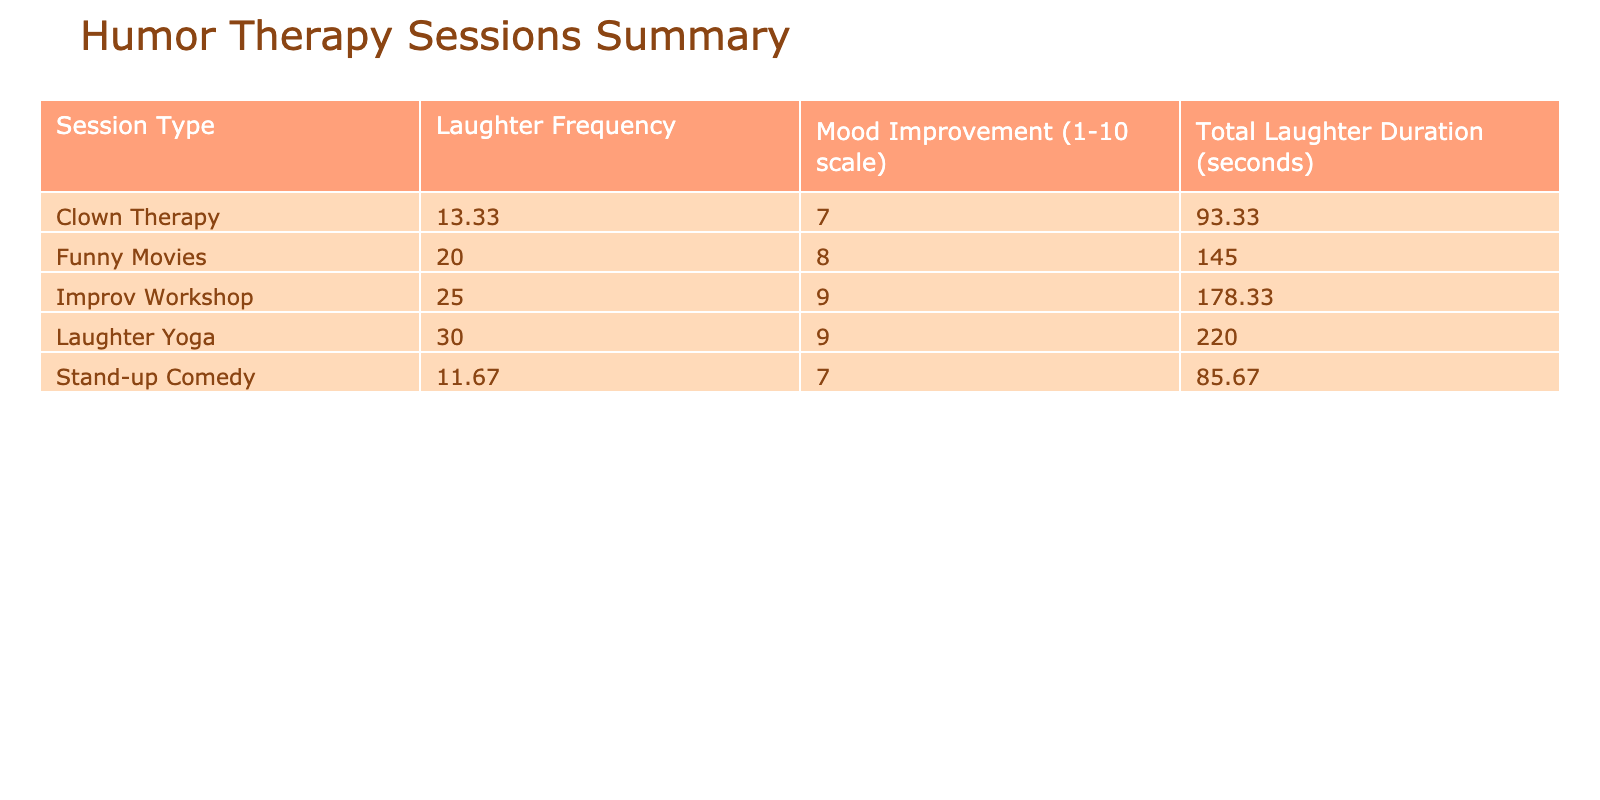What is the average laughter frequency during Funny Movies? The laughter frequencies for Funny Movies are 20, 18, and 22. To find the average, sum these values: 20 + 18 + 22 = 60, and then divide by the number of sessions (3): 60 / 3 = 20.
Answer: 20 Which session type had the highest mood improvement? Looking at the mood improvement scores: 7, 6, 8 (Stand-up Comedy), 8, 7, 9 (Funny Movies), 6, 8, 7 (Clown Therapy), 9, 8, 10 (Improv Workshop), 9, 8, 10 (Laughter Yoga). The highest score is 10 from the Improv Workshop.
Answer: Improv Workshop What is the total laughter duration for Clown Therapy sessions? The total laughter durations for Clown Therapy sessions are 70, 95, and 115 seconds. Summing these gives 70 + 95 + 115 = 280 seconds.
Answer: 280 seconds Is the average laughter duration in Laughter Yoga longer than in Stand-up Comedy? The average duration for Laughter Yoga is calculated as follows: (220 + 200 + 240) / 3 = 220 seconds. For Stand-up Comedy: (85 + 62 + 110) / 3 = 85.67 seconds. Since 220 > 85.67, the average laughter duration in Laughter Yoga is indeed longer.
Answer: Yes What is the difference in average laughter frequency between Improv Workshop and Clown Therapy? The average laughter frequency for Improv Workshop is (25 + 22 + 28) / 3 = 25. For Clown Therapy, it is (10 + 14 + 16) / 3 = 13.33. The difference between these averages is 25 - 13.33 = 11.67.
Answer: 11.67 